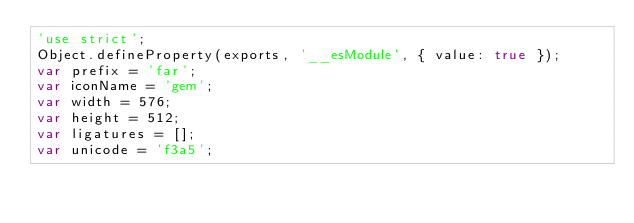Convert code to text. <code><loc_0><loc_0><loc_500><loc_500><_JavaScript_>'use strict';
Object.defineProperty(exports, '__esModule', { value: true });
var prefix = 'far';
var iconName = 'gem';
var width = 576;
var height = 512;
var ligatures = [];
var unicode = 'f3a5';</code> 